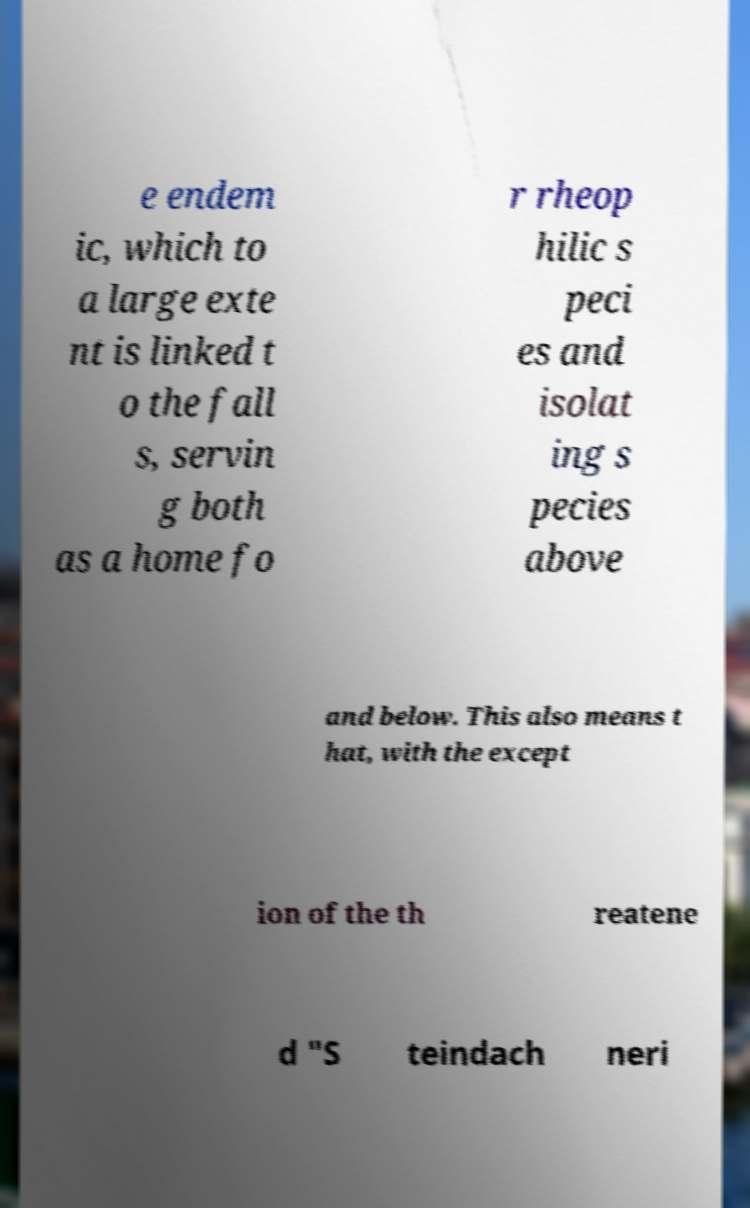For documentation purposes, I need the text within this image transcribed. Could you provide that? e endem ic, which to a large exte nt is linked t o the fall s, servin g both as a home fo r rheop hilic s peci es and isolat ing s pecies above and below. This also means t hat, with the except ion of the th reatene d "S teindach neri 